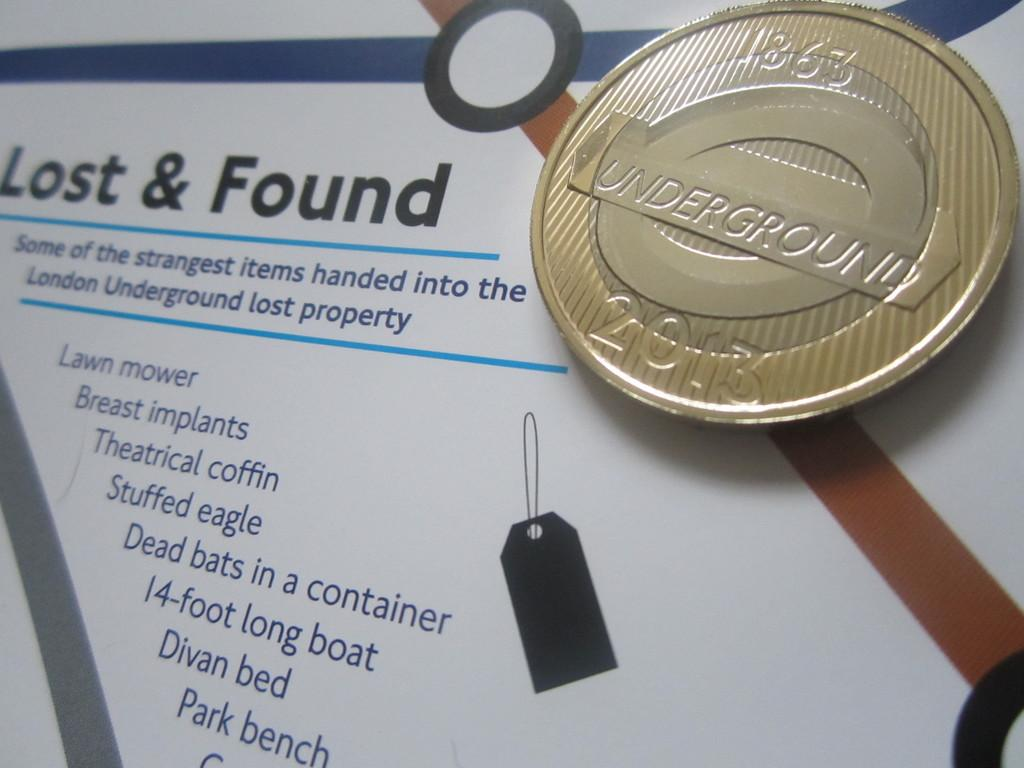<image>
Describe the image concisely. A list explains several items that have been left in lost and found. 